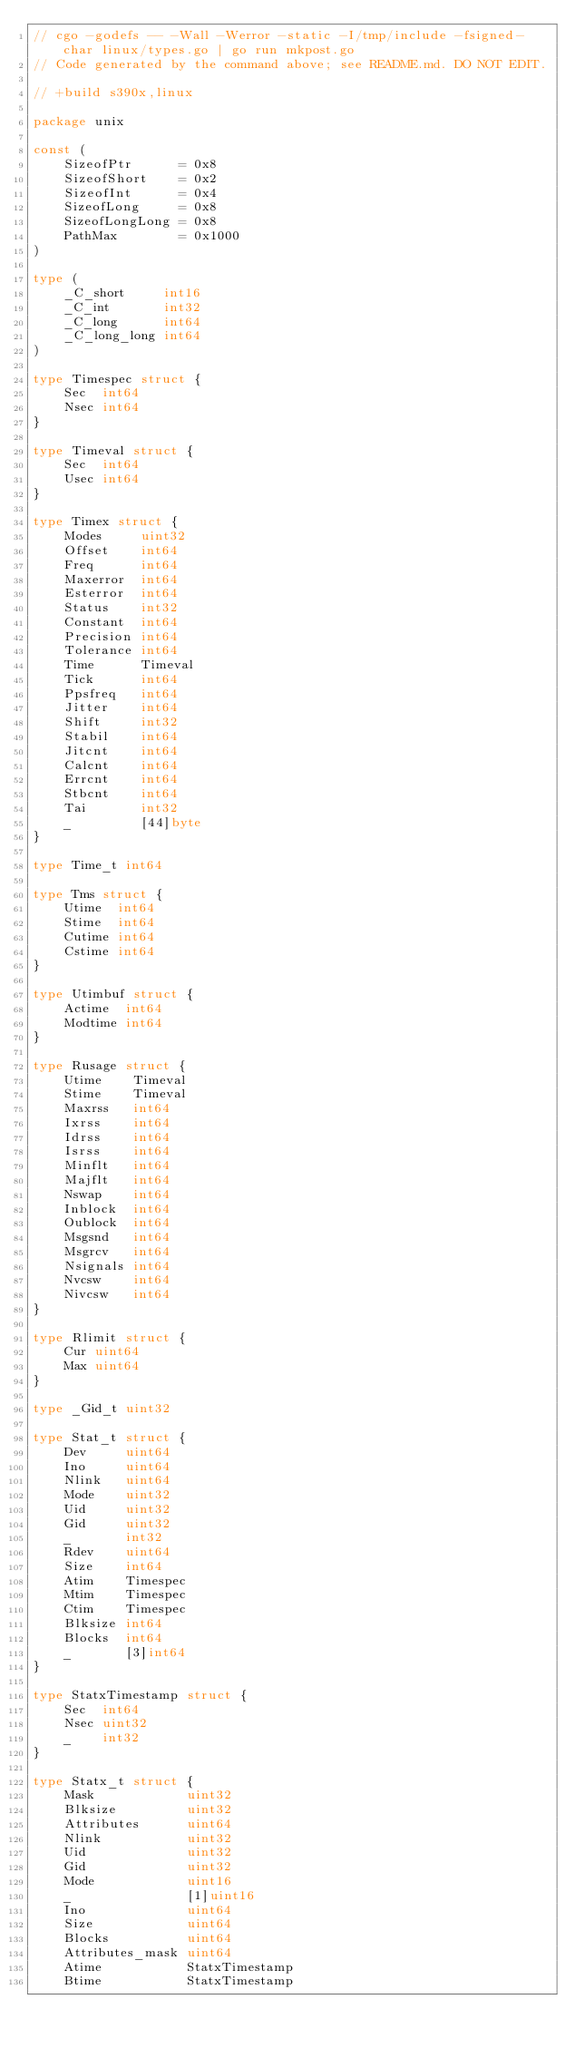Convert code to text. <code><loc_0><loc_0><loc_500><loc_500><_Go_>// cgo -godefs -- -Wall -Werror -static -I/tmp/include -fsigned-char linux/types.go | go run mkpost.go
// Code generated by the command above; see README.md. DO NOT EDIT.

// +build s390x,linux

package unix

const (
	SizeofPtr      = 0x8
	SizeofShort    = 0x2
	SizeofInt      = 0x4
	SizeofLong     = 0x8
	SizeofLongLong = 0x8
	PathMax        = 0x1000
)

type (
	_C_short     int16
	_C_int       int32
	_C_long      int64
	_C_long_long int64
)

type Timespec struct {
	Sec  int64
	Nsec int64
}

type Timeval struct {
	Sec  int64
	Usec int64
}

type Timex struct {
	Modes     uint32
	Offset    int64
	Freq      int64
	Maxerror  int64
	Esterror  int64
	Status    int32
	Constant  int64
	Precision int64
	Tolerance int64
	Time      Timeval
	Tick      int64
	Ppsfreq   int64
	Jitter    int64
	Shift     int32
	Stabil    int64
	Jitcnt    int64
	Calcnt    int64
	Errcnt    int64
	Stbcnt    int64
	Tai       int32
	_         [44]byte
}

type Time_t int64

type Tms struct {
	Utime  int64
	Stime  int64
	Cutime int64
	Cstime int64
}

type Utimbuf struct {
	Actime  int64
	Modtime int64
}

type Rusage struct {
	Utime    Timeval
	Stime    Timeval
	Maxrss   int64
	Ixrss    int64
	Idrss    int64
	Isrss    int64
	Minflt   int64
	Majflt   int64
	Nswap    int64
	Inblock  int64
	Oublock  int64
	Msgsnd   int64
	Msgrcv   int64
	Nsignals int64
	Nvcsw    int64
	Nivcsw   int64
}

type Rlimit struct {
	Cur uint64
	Max uint64
}

type _Gid_t uint32

type Stat_t struct {
	Dev     uint64
	Ino     uint64
	Nlink   uint64
	Mode    uint32
	Uid     uint32
	Gid     uint32
	_       int32
	Rdev    uint64
	Size    int64
	Atim    Timespec
	Mtim    Timespec
	Ctim    Timespec
	Blksize int64
	Blocks  int64
	_       [3]int64
}

type StatxTimestamp struct {
	Sec  int64
	Nsec uint32
	_    int32
}

type Statx_t struct {
	Mask            uint32
	Blksize         uint32
	Attributes      uint64
	Nlink           uint32
	Uid             uint32
	Gid             uint32
	Mode            uint16
	_               [1]uint16
	Ino             uint64
	Size            uint64
	Blocks          uint64
	Attributes_mask uint64
	Atime           StatxTimestamp
	Btime           StatxTimestamp</code> 